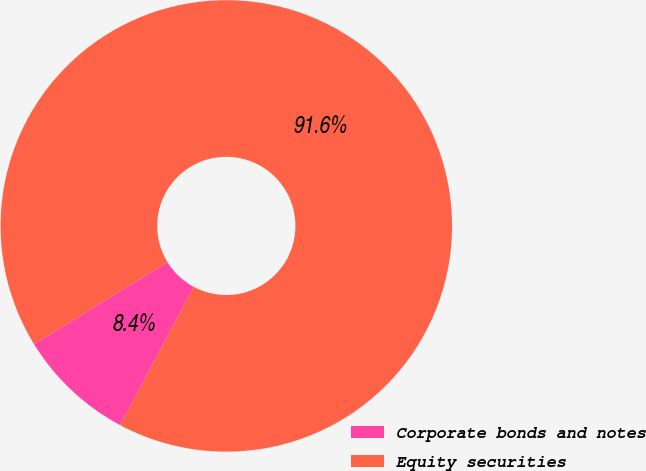<chart> <loc_0><loc_0><loc_500><loc_500><pie_chart><fcel>Corporate bonds and notes<fcel>Equity securities<nl><fcel>8.42%<fcel>91.58%<nl></chart> 